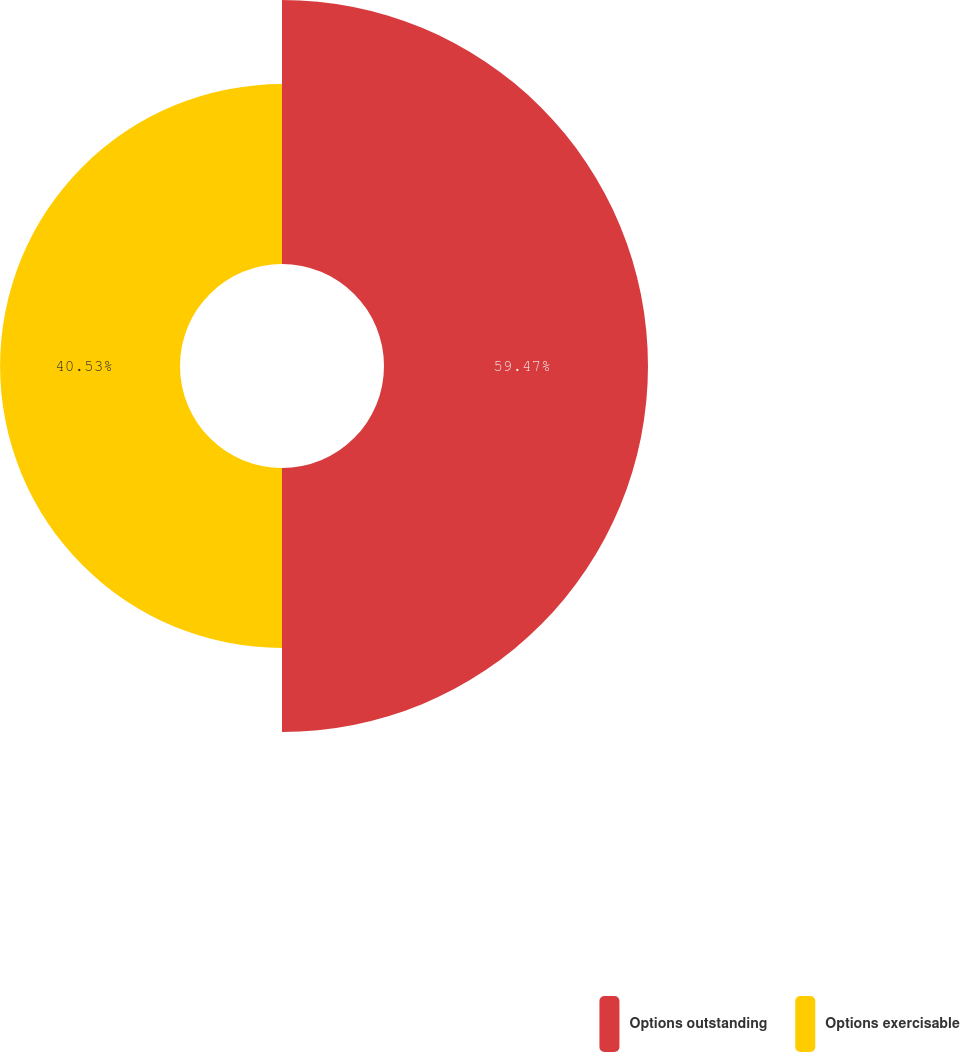Convert chart to OTSL. <chart><loc_0><loc_0><loc_500><loc_500><pie_chart><fcel>Options outstanding<fcel>Options exercisable<nl><fcel>59.47%<fcel>40.53%<nl></chart> 